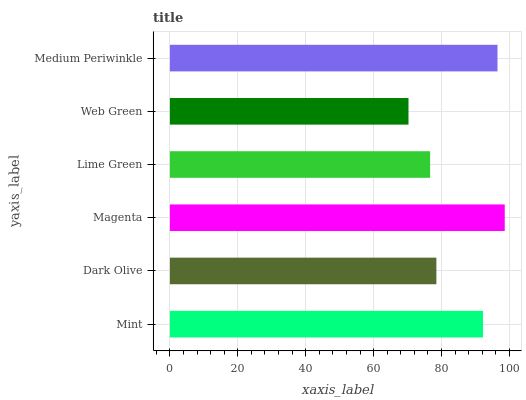Is Web Green the minimum?
Answer yes or no. Yes. Is Magenta the maximum?
Answer yes or no. Yes. Is Dark Olive the minimum?
Answer yes or no. No. Is Dark Olive the maximum?
Answer yes or no. No. Is Mint greater than Dark Olive?
Answer yes or no. Yes. Is Dark Olive less than Mint?
Answer yes or no. Yes. Is Dark Olive greater than Mint?
Answer yes or no. No. Is Mint less than Dark Olive?
Answer yes or no. No. Is Mint the high median?
Answer yes or no. Yes. Is Dark Olive the low median?
Answer yes or no. Yes. Is Lime Green the high median?
Answer yes or no. No. Is Mint the low median?
Answer yes or no. No. 